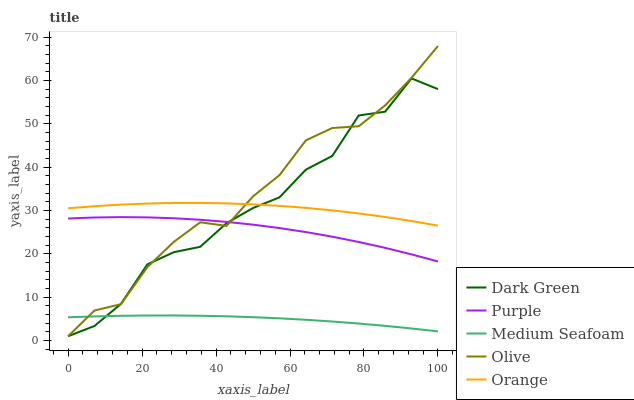Does Orange have the minimum area under the curve?
Answer yes or no. No. Does Orange have the maximum area under the curve?
Answer yes or no. No. Is Olive the smoothest?
Answer yes or no. No. Is Olive the roughest?
Answer yes or no. No. Does Orange have the lowest value?
Answer yes or no. No. Does Orange have the highest value?
Answer yes or no. No. Is Medium Seafoam less than Purple?
Answer yes or no. Yes. Is Orange greater than Purple?
Answer yes or no. Yes. Does Medium Seafoam intersect Purple?
Answer yes or no. No. 